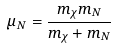Convert formula to latex. <formula><loc_0><loc_0><loc_500><loc_500>\mu _ { N } = \frac { m _ { \chi } m _ { N } } { m _ { \chi } + m _ { N } }</formula> 